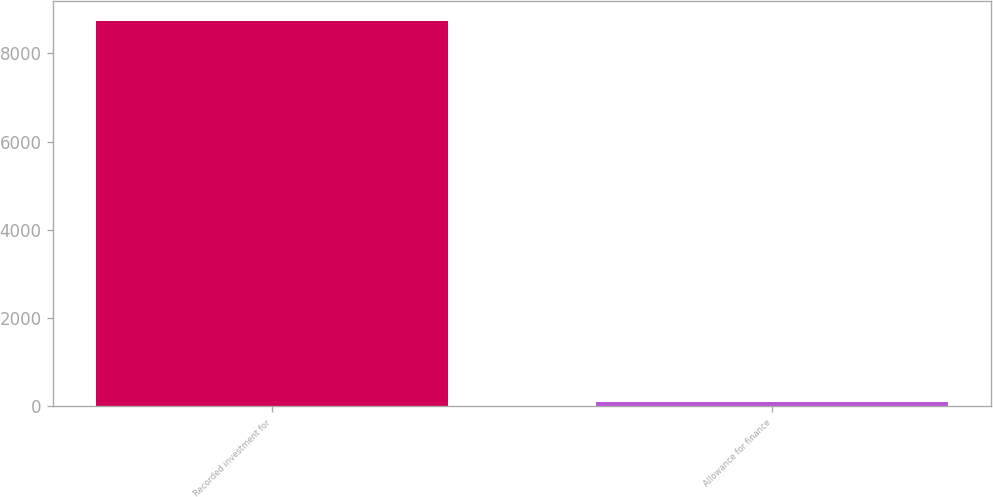Convert chart. <chart><loc_0><loc_0><loc_500><loc_500><bar_chart><fcel>Recorded investment for<fcel>Allowance for finance<nl><fcel>8740.3<fcel>97.6<nl></chart> 